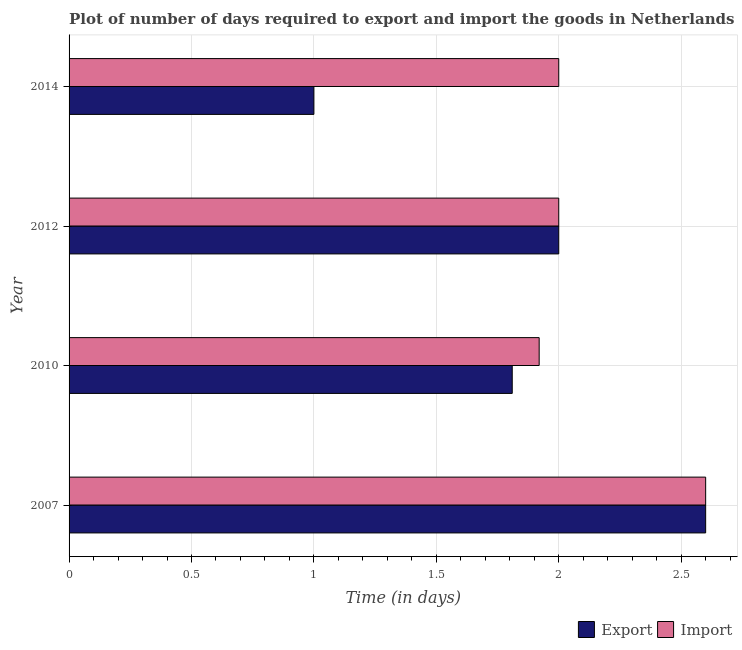How many different coloured bars are there?
Keep it short and to the point. 2. How many bars are there on the 2nd tick from the top?
Your response must be concise. 2. How many bars are there on the 3rd tick from the bottom?
Your answer should be very brief. 2. What is the label of the 2nd group of bars from the top?
Offer a terse response. 2012. In how many cases, is the number of bars for a given year not equal to the number of legend labels?
Provide a succinct answer. 0. Across all years, what is the maximum time required to export?
Provide a short and direct response. 2.6. Across all years, what is the minimum time required to import?
Ensure brevity in your answer.  1.92. What is the total time required to import in the graph?
Make the answer very short. 8.52. What is the difference between the time required to export in 2007 and that in 2010?
Ensure brevity in your answer.  0.79. What is the difference between the time required to export in 2010 and the time required to import in 2014?
Your answer should be compact. -0.19. What is the average time required to export per year?
Provide a short and direct response. 1.85. In the year 2007, what is the difference between the time required to export and time required to import?
Provide a succinct answer. 0. What is the ratio of the time required to export in 2010 to that in 2012?
Your answer should be very brief. 0.91. What is the difference between the highest and the second highest time required to export?
Keep it short and to the point. 0.6. What is the difference between the highest and the lowest time required to import?
Ensure brevity in your answer.  0.68. In how many years, is the time required to import greater than the average time required to import taken over all years?
Provide a succinct answer. 1. Is the sum of the time required to export in 2010 and 2014 greater than the maximum time required to import across all years?
Keep it short and to the point. Yes. What does the 1st bar from the top in 2007 represents?
Your response must be concise. Import. What does the 1st bar from the bottom in 2007 represents?
Your answer should be very brief. Export. Are all the bars in the graph horizontal?
Make the answer very short. Yes. Are the values on the major ticks of X-axis written in scientific E-notation?
Your answer should be very brief. No. Where does the legend appear in the graph?
Give a very brief answer. Bottom right. How many legend labels are there?
Provide a succinct answer. 2. How are the legend labels stacked?
Give a very brief answer. Horizontal. What is the title of the graph?
Provide a succinct answer. Plot of number of days required to export and import the goods in Netherlands. What is the label or title of the X-axis?
Give a very brief answer. Time (in days). What is the label or title of the Y-axis?
Ensure brevity in your answer.  Year. What is the Time (in days) of Export in 2007?
Ensure brevity in your answer.  2.6. What is the Time (in days) of Export in 2010?
Provide a short and direct response. 1.81. What is the Time (in days) of Import in 2010?
Keep it short and to the point. 1.92. What is the Time (in days) of Export in 2012?
Your answer should be very brief. 2. What is the Time (in days) in Import in 2012?
Your response must be concise. 2. What is the Time (in days) of Export in 2014?
Keep it short and to the point. 1. Across all years, what is the maximum Time (in days) of Import?
Give a very brief answer. 2.6. Across all years, what is the minimum Time (in days) in Export?
Ensure brevity in your answer.  1. Across all years, what is the minimum Time (in days) of Import?
Provide a succinct answer. 1.92. What is the total Time (in days) in Export in the graph?
Your answer should be very brief. 7.41. What is the total Time (in days) of Import in the graph?
Provide a short and direct response. 8.52. What is the difference between the Time (in days) of Export in 2007 and that in 2010?
Give a very brief answer. 0.79. What is the difference between the Time (in days) in Import in 2007 and that in 2010?
Make the answer very short. 0.68. What is the difference between the Time (in days) of Export in 2010 and that in 2012?
Your response must be concise. -0.19. What is the difference between the Time (in days) in Import in 2010 and that in 2012?
Ensure brevity in your answer.  -0.08. What is the difference between the Time (in days) in Export in 2010 and that in 2014?
Your answer should be compact. 0.81. What is the difference between the Time (in days) in Import in 2010 and that in 2014?
Your answer should be compact. -0.08. What is the difference between the Time (in days) of Import in 2012 and that in 2014?
Your answer should be compact. 0. What is the difference between the Time (in days) in Export in 2007 and the Time (in days) in Import in 2010?
Make the answer very short. 0.68. What is the difference between the Time (in days) in Export in 2010 and the Time (in days) in Import in 2012?
Provide a succinct answer. -0.19. What is the difference between the Time (in days) in Export in 2010 and the Time (in days) in Import in 2014?
Provide a short and direct response. -0.19. What is the average Time (in days) of Export per year?
Ensure brevity in your answer.  1.85. What is the average Time (in days) in Import per year?
Your answer should be very brief. 2.13. In the year 2007, what is the difference between the Time (in days) in Export and Time (in days) in Import?
Your response must be concise. 0. In the year 2010, what is the difference between the Time (in days) of Export and Time (in days) of Import?
Make the answer very short. -0.11. In the year 2012, what is the difference between the Time (in days) of Export and Time (in days) of Import?
Give a very brief answer. 0. What is the ratio of the Time (in days) of Export in 2007 to that in 2010?
Offer a very short reply. 1.44. What is the ratio of the Time (in days) of Import in 2007 to that in 2010?
Your answer should be very brief. 1.35. What is the ratio of the Time (in days) in Export in 2007 to that in 2012?
Keep it short and to the point. 1.3. What is the ratio of the Time (in days) in Export in 2007 to that in 2014?
Make the answer very short. 2.6. What is the ratio of the Time (in days) of Import in 2007 to that in 2014?
Ensure brevity in your answer.  1.3. What is the ratio of the Time (in days) in Export in 2010 to that in 2012?
Your answer should be compact. 0.91. What is the ratio of the Time (in days) in Import in 2010 to that in 2012?
Provide a short and direct response. 0.96. What is the ratio of the Time (in days) in Export in 2010 to that in 2014?
Give a very brief answer. 1.81. What is the difference between the highest and the second highest Time (in days) of Export?
Provide a succinct answer. 0.6. What is the difference between the highest and the second highest Time (in days) of Import?
Provide a succinct answer. 0.6. What is the difference between the highest and the lowest Time (in days) in Import?
Give a very brief answer. 0.68. 